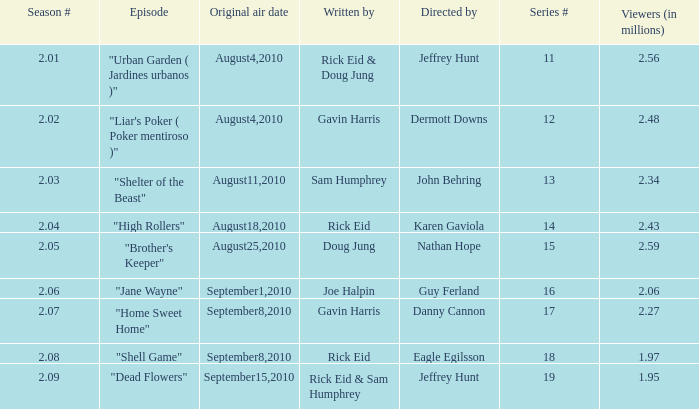What is the series minimum if the season number is 2.08? 18.0. 